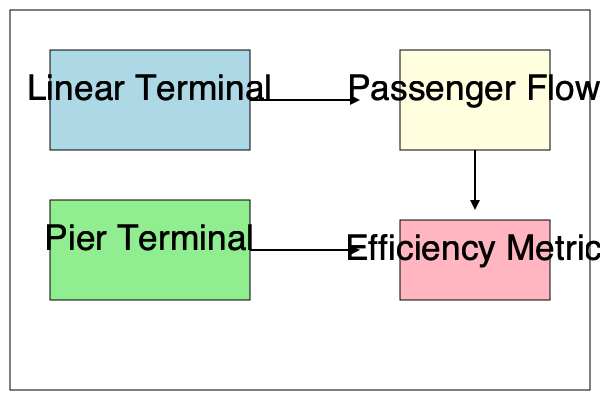Based on the flow diagram comparing a linear terminal design to a pier terminal design, which layout would likely result in a higher passenger flow efficiency metric, and why? To analyze the impact of different airport terminal designs on passenger flow, we need to consider several factors:

1. Walking distances: 
   - Linear terminal: Shorter average walking distances for passengers
   - Pier terminal: Longer average walking distances due to extended corridors

2. Congestion points:
   - Linear terminal: Fewer congestion points, more evenly distributed passenger flow
   - Pier terminal: More potential congestion points at pier intersections

3. Wayfinding:
   - Linear terminal: Simpler layout, easier for passengers to navigate
   - Pier terminal: More complex layout, potentially confusing for passengers

4. Flexibility:
   - Linear terminal: Limited expansion capabilities
   - Pier terminal: More flexible for future expansion

5. Gate accessibility:
   - Linear terminal: Direct access to all gates
   - Pier terminal: Some gates further from the main terminal

6. Passenger flow calculation:
   Let $P$ be the number of passengers, $D$ be the average walking distance, and $T$ be the average time spent navigating.
   Efficiency metric $E$ can be expressed as:
   
   $$ E = \frac{P}{D \times T} $$

   The linear terminal design would likely have a lower $D$ and $T$, resulting in a higher efficiency metric $E$.

Given these factors, the linear terminal design would likely result in a higher passenger flow efficiency metric. It offers shorter walking distances, fewer congestion points, and easier wayfinding, all of which contribute to smoother and faster passenger movement through the terminal.
Answer: Linear terminal design, due to shorter walking distances and fewer congestion points. 